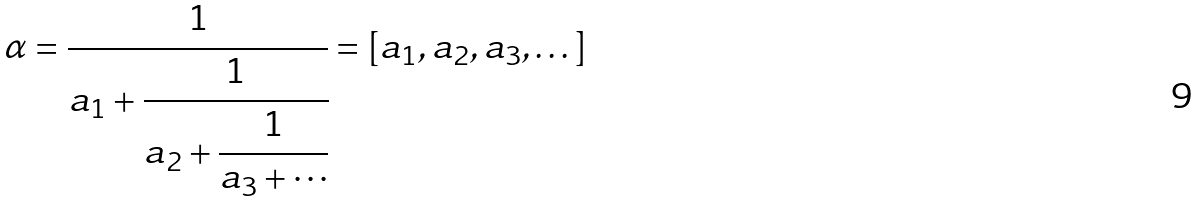Convert formula to latex. <formula><loc_0><loc_0><loc_500><loc_500>\alpha = \cfrac { 1 } { a _ { 1 } + \cfrac { 1 } { a _ { 2 } + \cfrac { 1 } { a _ { 3 } + \cdots } } } = [ a _ { 1 } , a _ { 2 } , a _ { 3 } , \dots ]</formula> 